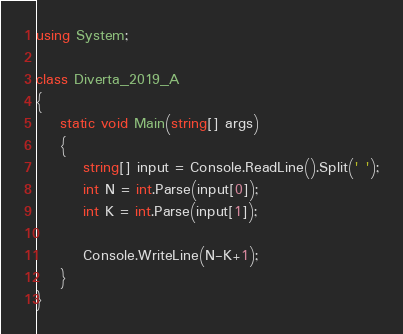<code> <loc_0><loc_0><loc_500><loc_500><_C#_>using System;

class Diverta_2019_A
{
    static void Main(string[] args)
    {
        string[] input = Console.ReadLine().Split(' ');
        int N = int.Parse(input[0]);
        int K = int.Parse(input[1]);

        Console.WriteLine(N-K+1);
    }
}</code> 